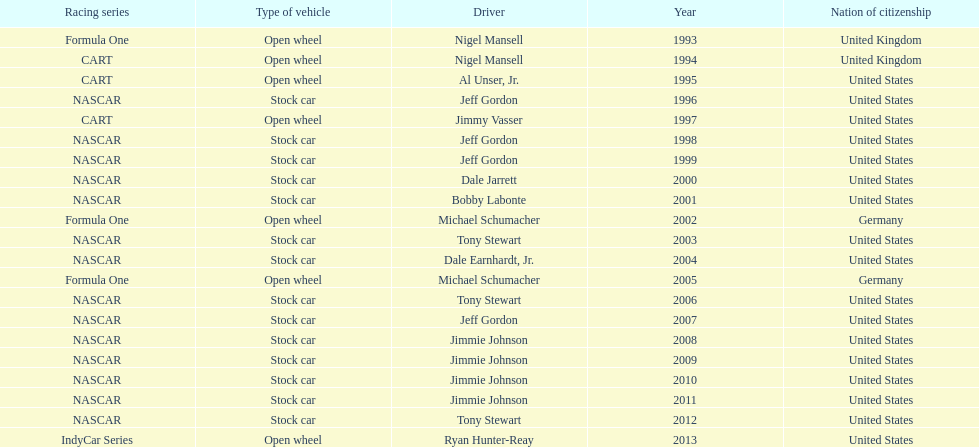Out of these drivers: nigel mansell, al unser, jr., michael schumacher, and jeff gordon, all but one has more than one espy award. who only has one espy award? Al Unser, Jr. 